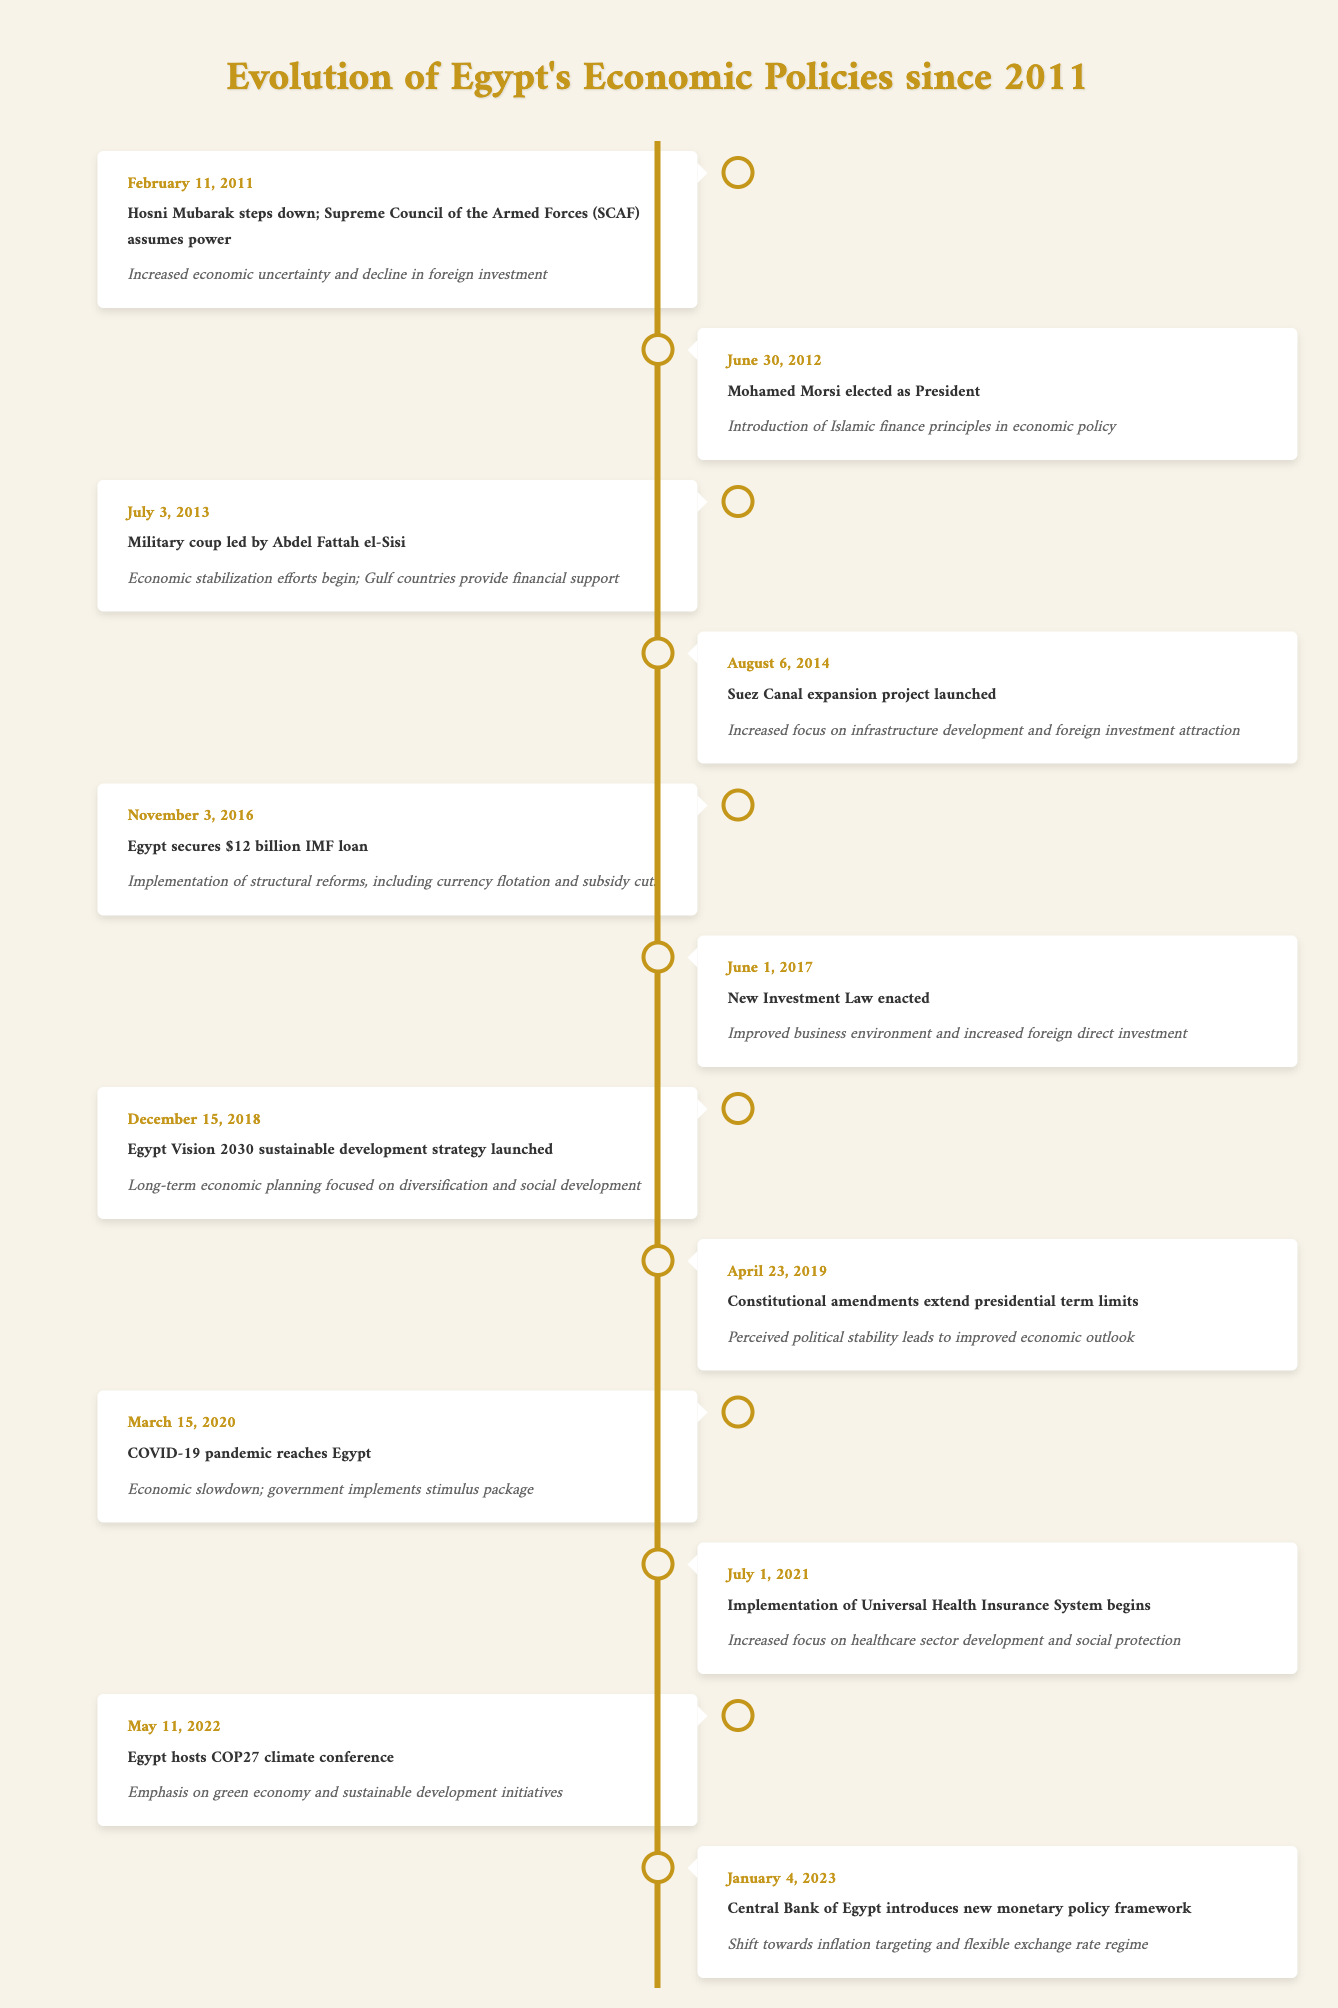What significant event occurred on February 11, 2011? The table lists the event where Hosni Mubarak stepped down and the Supreme Council of the Armed Forces assumed power. This is a significant political change in Egypt.
Answer: Hosni Mubarak steps down; Supreme Council of the Armed Forces assumes power What was the economic impact of the military coup on July 3, 2013? The timeline indicates that after the military coup led by Abdel Fattah el-Sisi, economic stabilization efforts began and Gulf countries provided financial support.
Answer: Economic stabilization efforts begin; Gulf countries provide financial support Which economic reforms were implemented after Egypt secured the IMF loan in November 2016? According to the table, the key reforms included currency flotation and subsidy cuts as part of the structural reforms that were implemented following the IMF loan of $12 billion.
Answer: Implementation of structural reforms, including currency flotation and subsidy cuts Did the launch of Egypt Vision 2030 in December 2018 focus on short-term or long-term economic planning? The table specifies that Egypt Vision 2030 emphasized long-term economic planning focused on diversification and social development, indicating a long-term approach.
Answer: Long-term economic planning What is the economic impact of the Suez Canal expansion project launched on August 6, 2014? The timeline details that the Suez Canal expansion project increased focus on infrastructure development and foreign investment attraction, which reflects its economic importance.
Answer: Increased focus on infrastructure development and foreign investment attraction What were the effects of the COVID-19 pandemic on Egypt's economy in March 2020? The data shows that the pandemic led to an economic slowdown, prompting the government to implement a stimulus package to support the economy during this difficult time.
Answer: Economic slowdown; government implements stimulus package What change in monetary policy was introduced by the Central Bank of Egypt on January 4, 2023? The table states that a new monetary policy framework was introduced, shifting towards inflation targeting and a flexible exchange rate regime, indicating significant economic policy changes.
Answer: Shift towards inflation targeting and flexible exchange rate regime Was there a major shift in Egypt's investment law after June 2017? The timeline indicates that a New Investment Law was enacted on June 1, 2017, which improved the business environment and increased foreign direct investment, signifying a positive shift.
Answer: Yes What was the perceived outcome of the constitutional amendments made on April 23, 2019? Based on the information in the table, the constitutional amendments extended presidential term limits, which led to a perceived political stability and an improved economic outlook.
Answer: Perceived political stability leads to improved economic outlook 